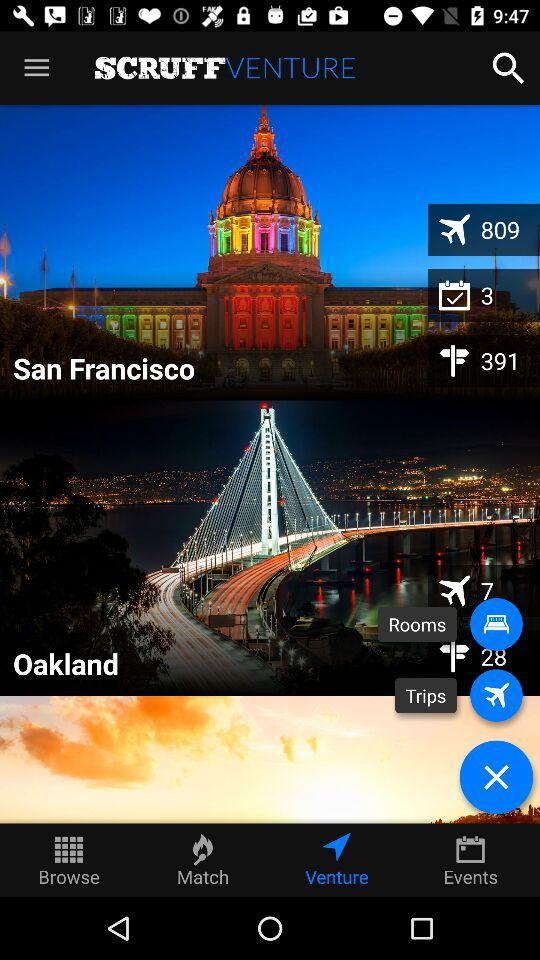What is the application name? The application name is "SCRUFF". 